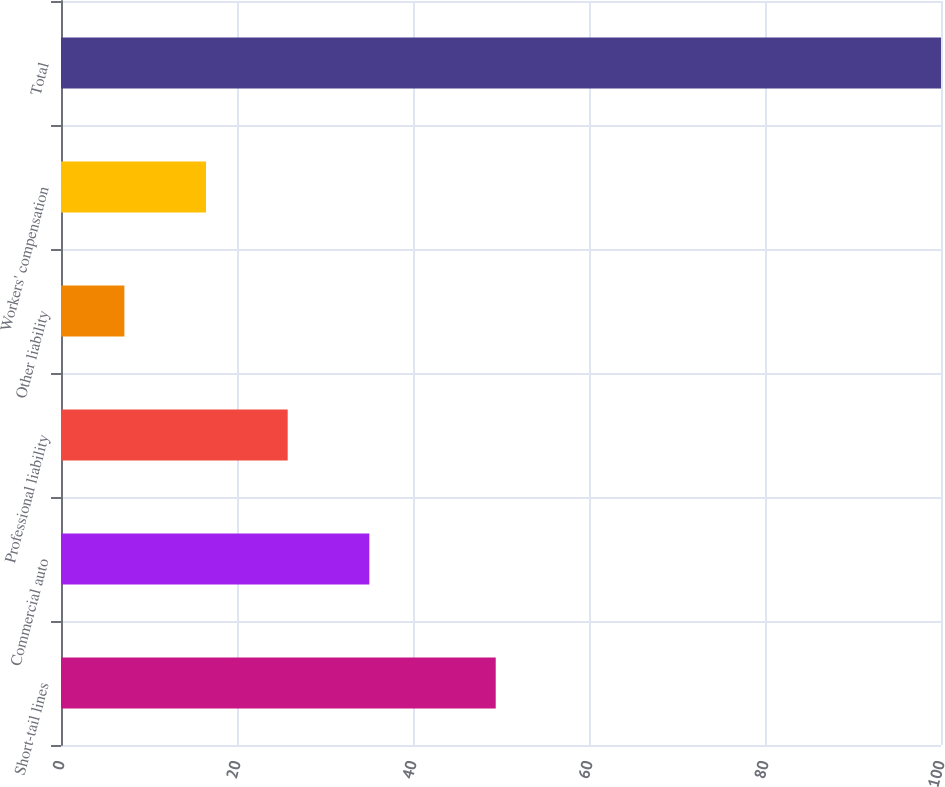Convert chart. <chart><loc_0><loc_0><loc_500><loc_500><bar_chart><fcel>Short-tail lines<fcel>Commercial auto<fcel>Professional liability<fcel>Other liability<fcel>Workers' compensation<fcel>Total<nl><fcel>49.4<fcel>35.04<fcel>25.76<fcel>7.2<fcel>16.48<fcel>100<nl></chart> 